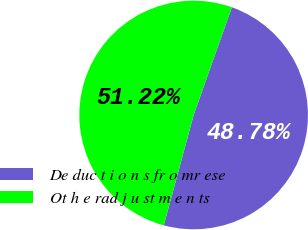Convert chart. <chart><loc_0><loc_0><loc_500><loc_500><pie_chart><fcel>De duc t i o n s fr o mr ese<fcel>Ot h e rad j u st m e n ts<nl><fcel>48.78%<fcel>51.22%<nl></chart> 